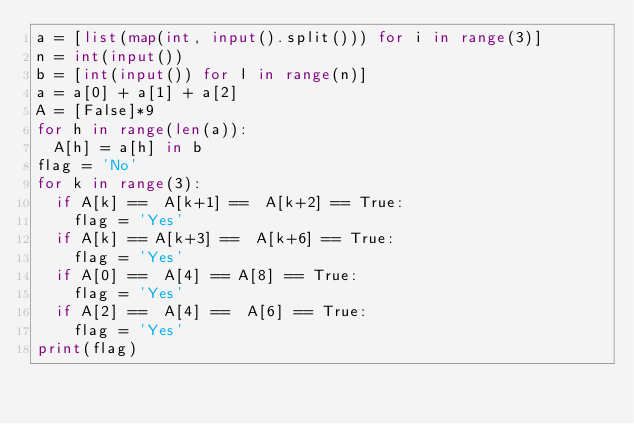Convert code to text. <code><loc_0><loc_0><loc_500><loc_500><_Python_>a = [list(map(int, input().split())) for i in range(3)]
n = int(input())
b = [int(input()) for l in range(n)]
a = a[0] + a[1] + a[2]
A = [False]*9
for h in range(len(a)):
  A[h] = a[h] in b
flag = 'No'
for k in range(3):
  if A[k] ==  A[k+1] ==  A[k+2] == True:
    flag = 'Yes'
  if A[k] == A[k+3] ==  A[k+6] == True:
    flag = 'Yes'
  if A[0] ==  A[4] == A[8] == True:
    flag = 'Yes'
  if A[2] ==  A[4] ==  A[6] == True:
    flag = 'Yes'
print(flag)</code> 